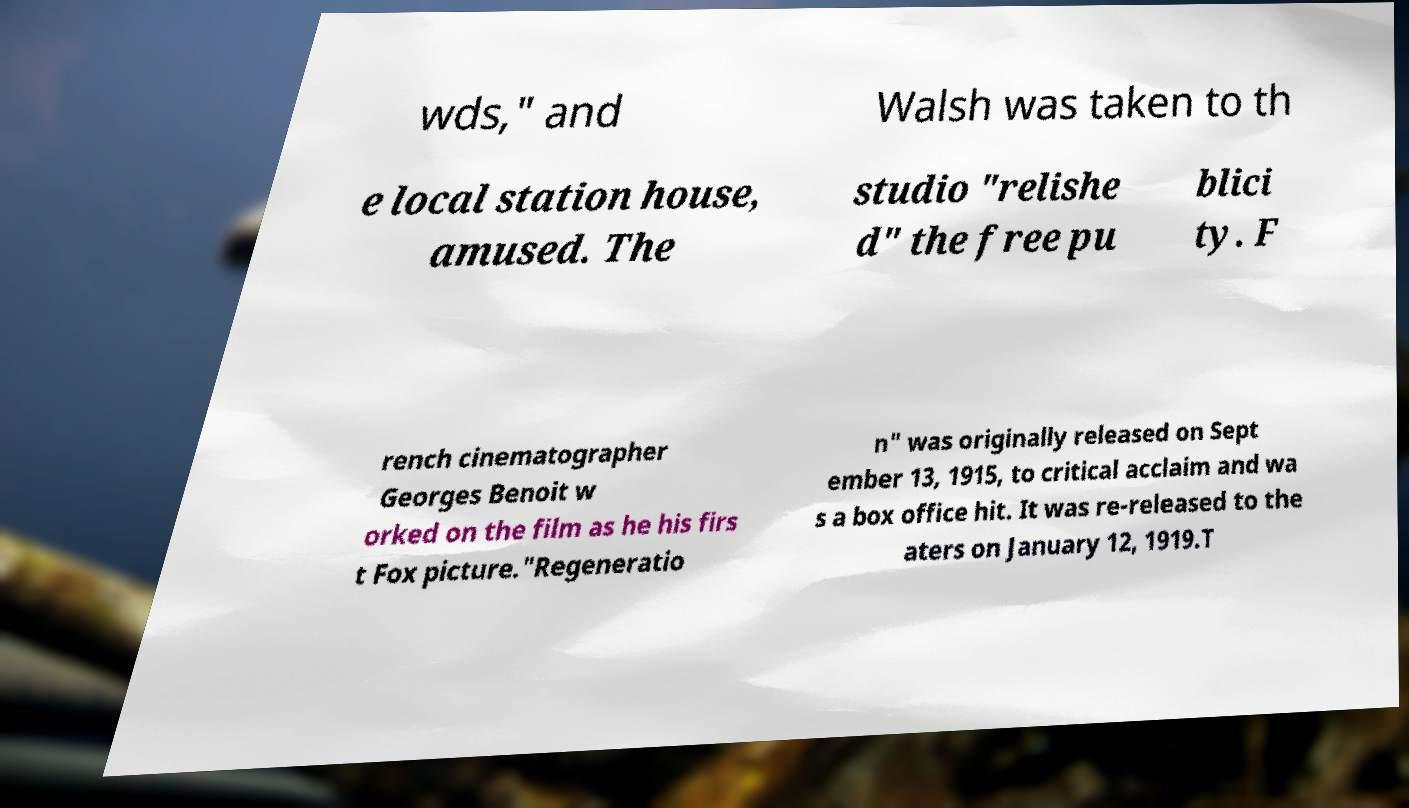Please read and relay the text visible in this image. What does it say? wds," and Walsh was taken to th e local station house, amused. The studio "relishe d" the free pu blici ty. F rench cinematographer Georges Benoit w orked on the film as he his firs t Fox picture."Regeneratio n" was originally released on Sept ember 13, 1915, to critical acclaim and wa s a box office hit. It was re-released to the aters on January 12, 1919.T 